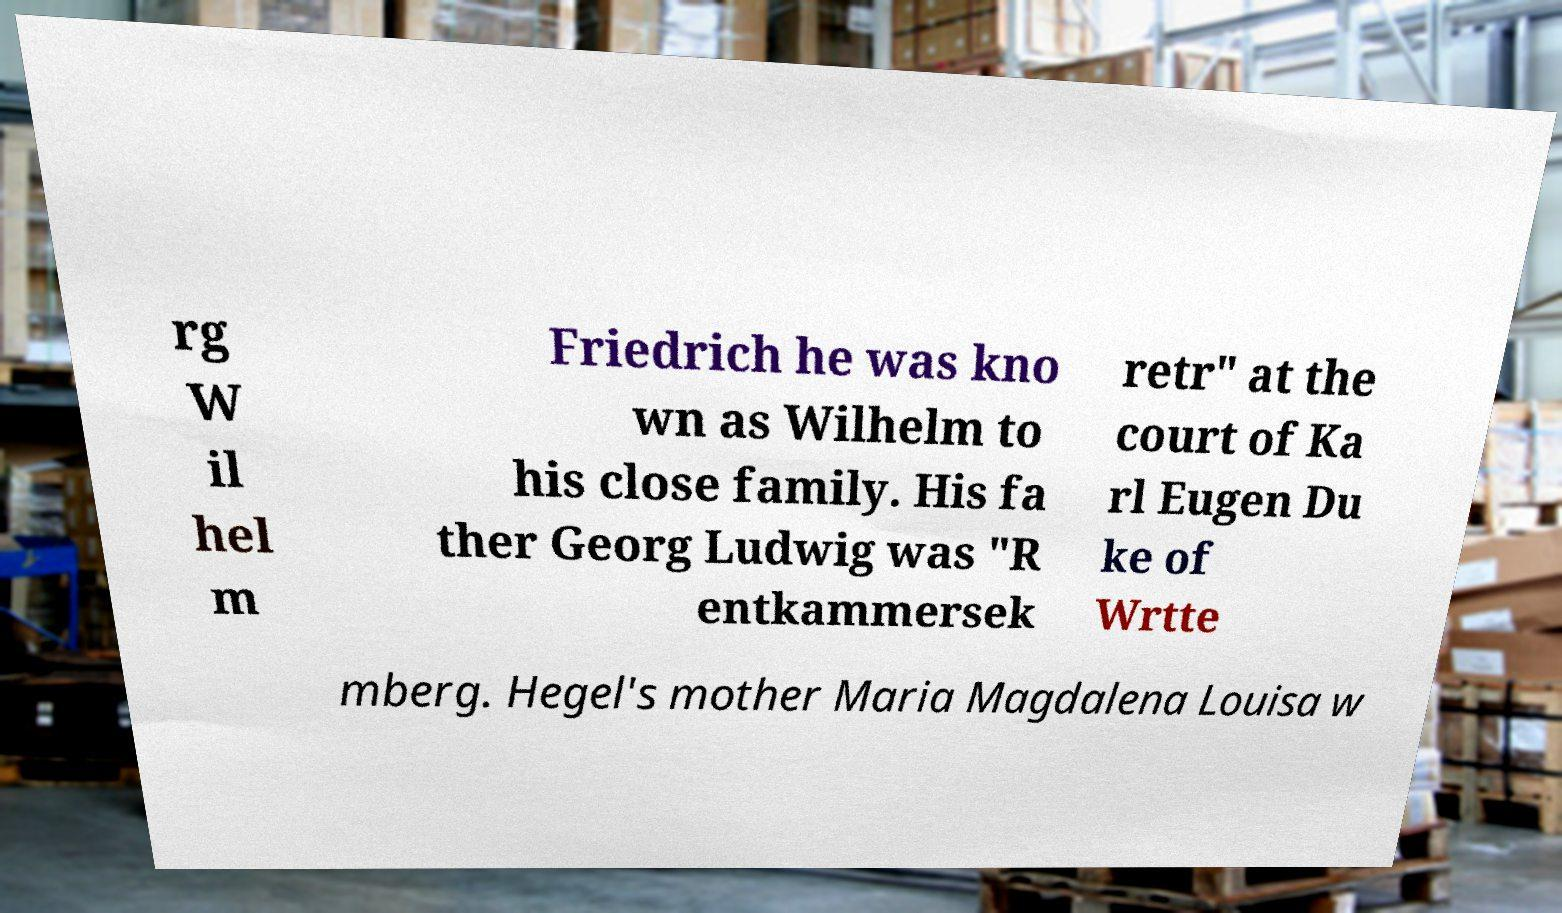Can you accurately transcribe the text from the provided image for me? rg W il hel m Friedrich he was kno wn as Wilhelm to his close family. His fa ther Georg Ludwig was "R entkammersek retr" at the court of Ka rl Eugen Du ke of Wrtte mberg. Hegel's mother Maria Magdalena Louisa w 